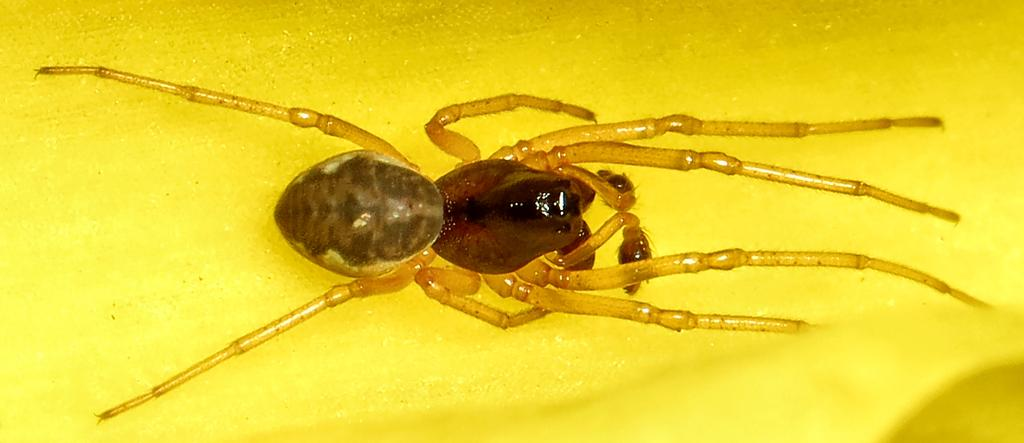What is the main subject of the image? There is an insect in the center of the image. What color is the background of the image? The background of the image is yellow. What time of day is it in the image, given the presence of a deer? There is no deer present in the image, so we cannot determine the time of day based on that information. 